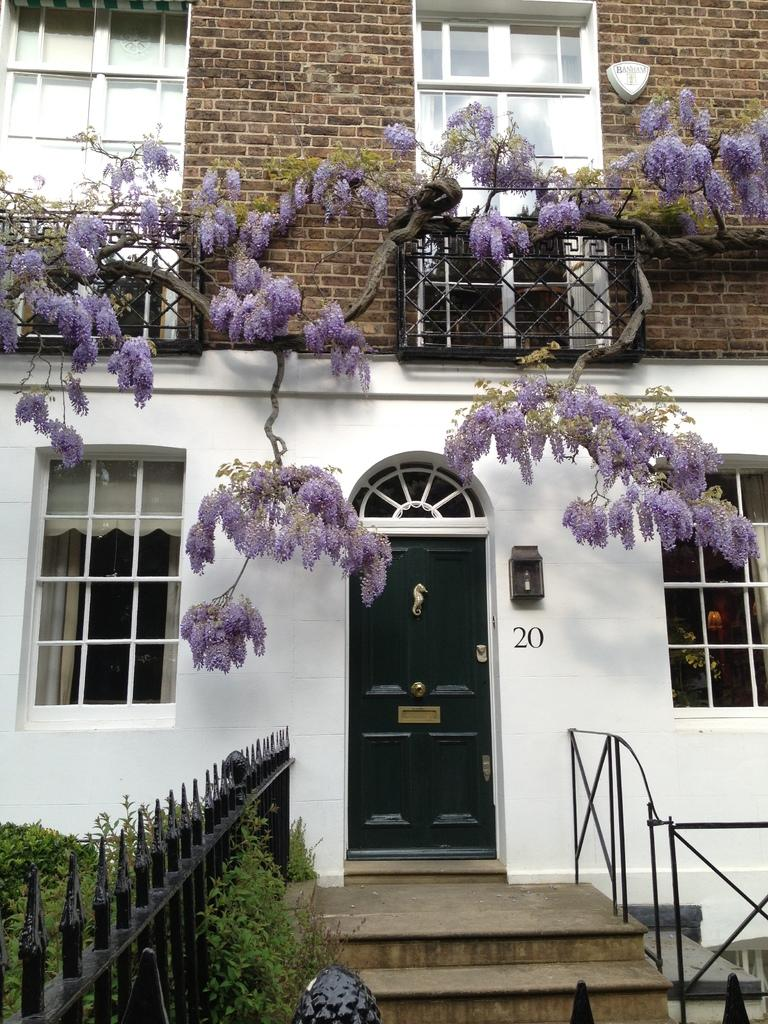What type of structure is visible in the image? There is a building in the image. What features can be seen on the building? The building has windows, a door, stairs, a railing, and fencing. Is there any indication of the building's address or identification? Yes, there is a number on the building. What type of vegetation is present in the image? There are plants and flowers in the image. What type of invention is being demonstrated in the image? There is no invention being demonstrated in the image; it features a building with various architectural features and vegetation. Can you tell me how many wheels are visible in the image? There are no wheels present in the image. 